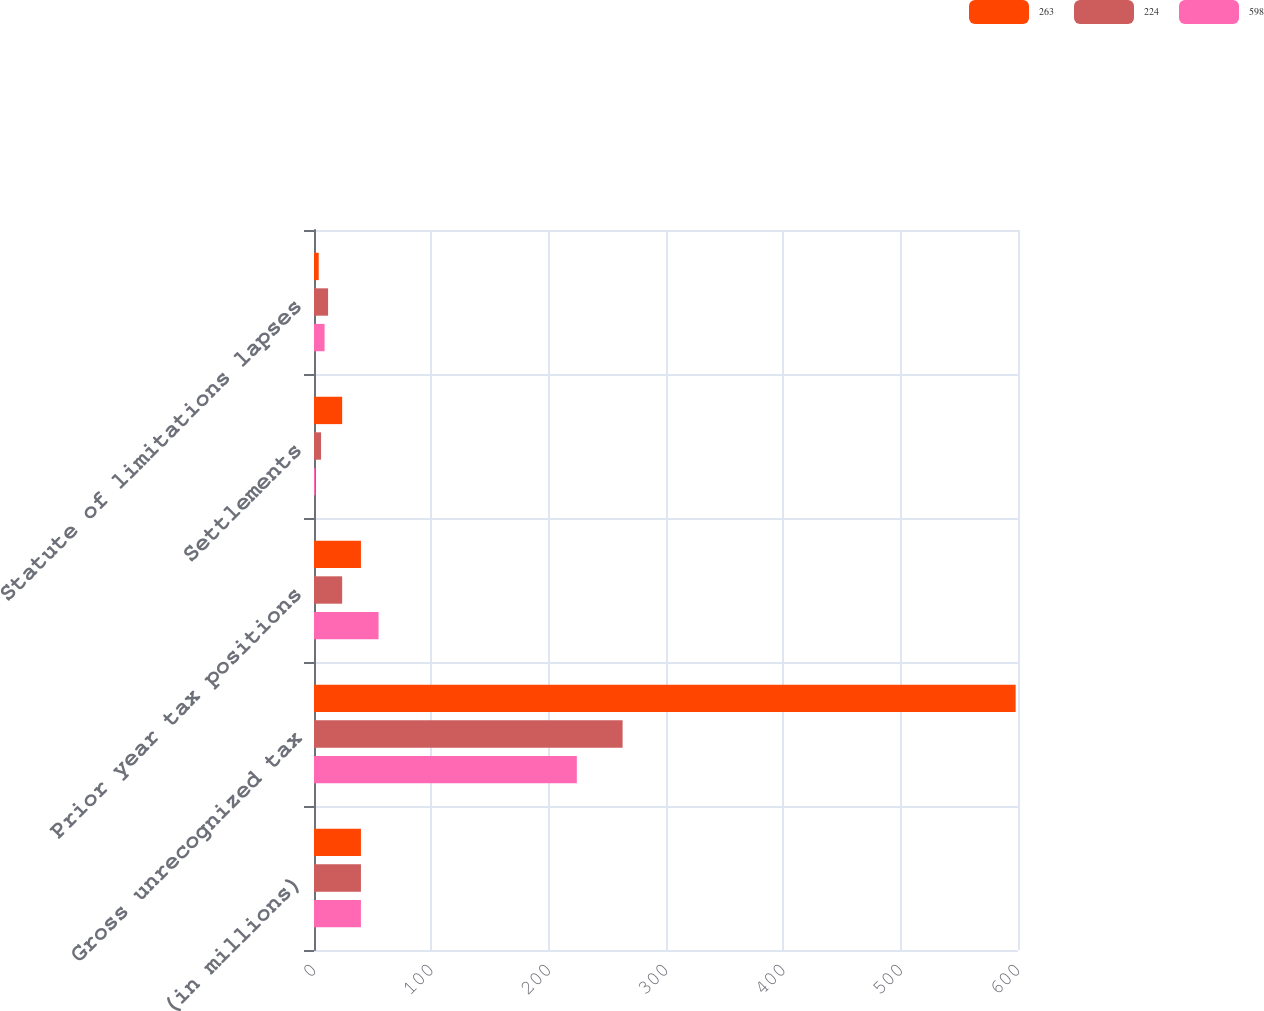Convert chart. <chart><loc_0><loc_0><loc_500><loc_500><stacked_bar_chart><ecel><fcel>(in millions)<fcel>Gross unrecognized tax<fcel>Prior year tax positions<fcel>Settlements<fcel>Statute of limitations lapses<nl><fcel>263<fcel>40<fcel>598<fcel>40<fcel>24<fcel>4<nl><fcel>224<fcel>40<fcel>263<fcel>24<fcel>6<fcel>12<nl><fcel>598<fcel>40<fcel>224<fcel>55<fcel>1<fcel>9<nl></chart> 